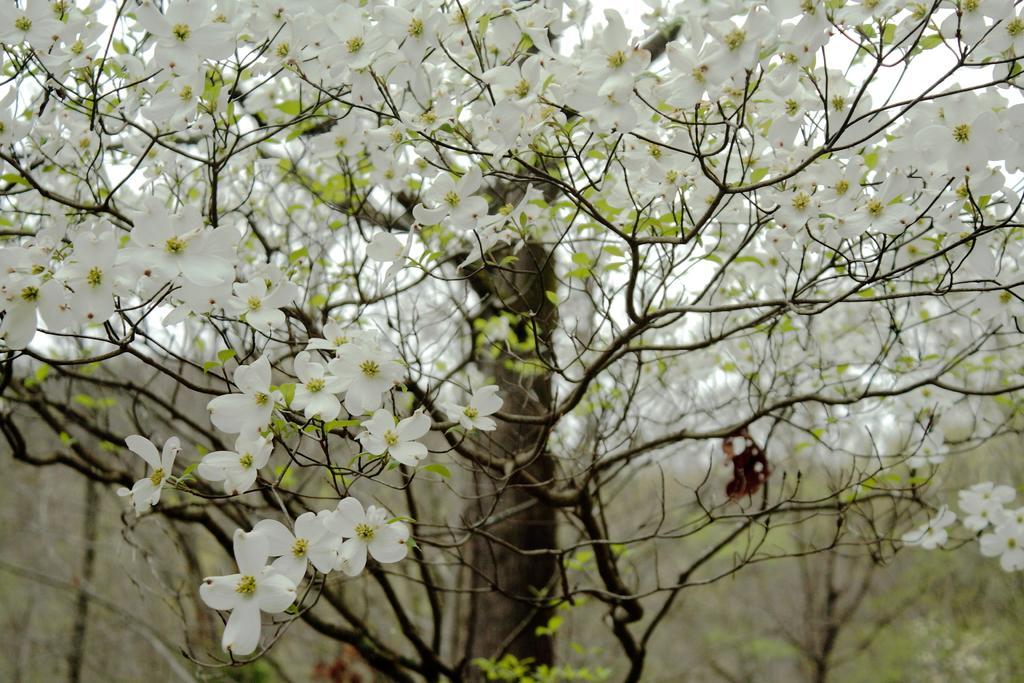Could you give a brief overview of what you see in this image? In this image I can see the flowers. In the background, I can see the trees. 